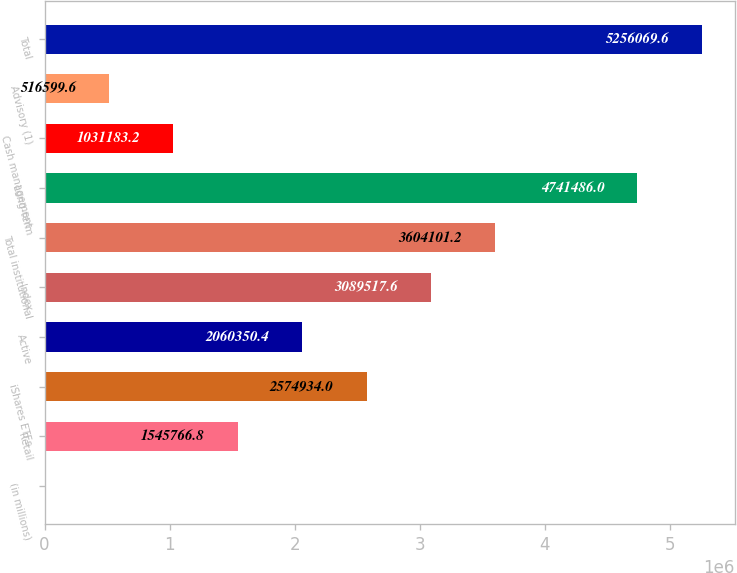<chart> <loc_0><loc_0><loc_500><loc_500><bar_chart><fcel>(in millions)<fcel>Retail<fcel>iShares ETFs<fcel>Active<fcel>Index<fcel>Total institutional<fcel>Long-term<fcel>Cash management<fcel>Advisory (1)<fcel>Total<nl><fcel>2016<fcel>1.54577e+06<fcel>2.57493e+06<fcel>2.06035e+06<fcel>3.08952e+06<fcel>3.6041e+06<fcel>4.74149e+06<fcel>1.03118e+06<fcel>516600<fcel>5.25607e+06<nl></chart> 